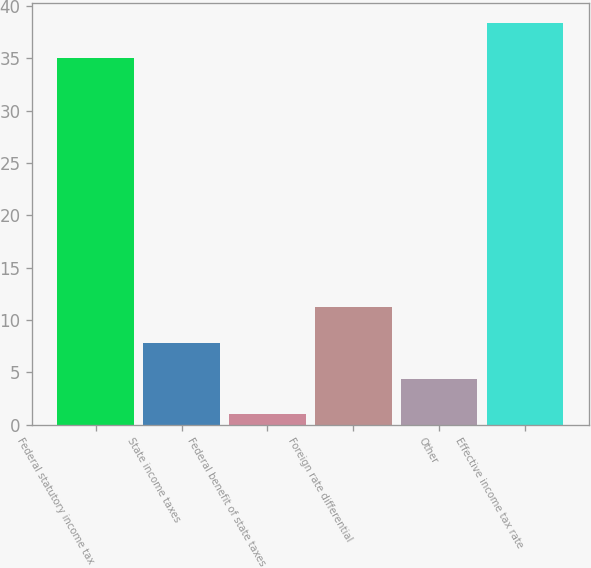<chart> <loc_0><loc_0><loc_500><loc_500><bar_chart><fcel>Federal statutory income tax<fcel>State income taxes<fcel>Federal benefit of state taxes<fcel>Foreign rate differential<fcel>Other<fcel>Effective income tax rate<nl><fcel>35<fcel>7.8<fcel>1<fcel>11.2<fcel>4.4<fcel>38.4<nl></chart> 